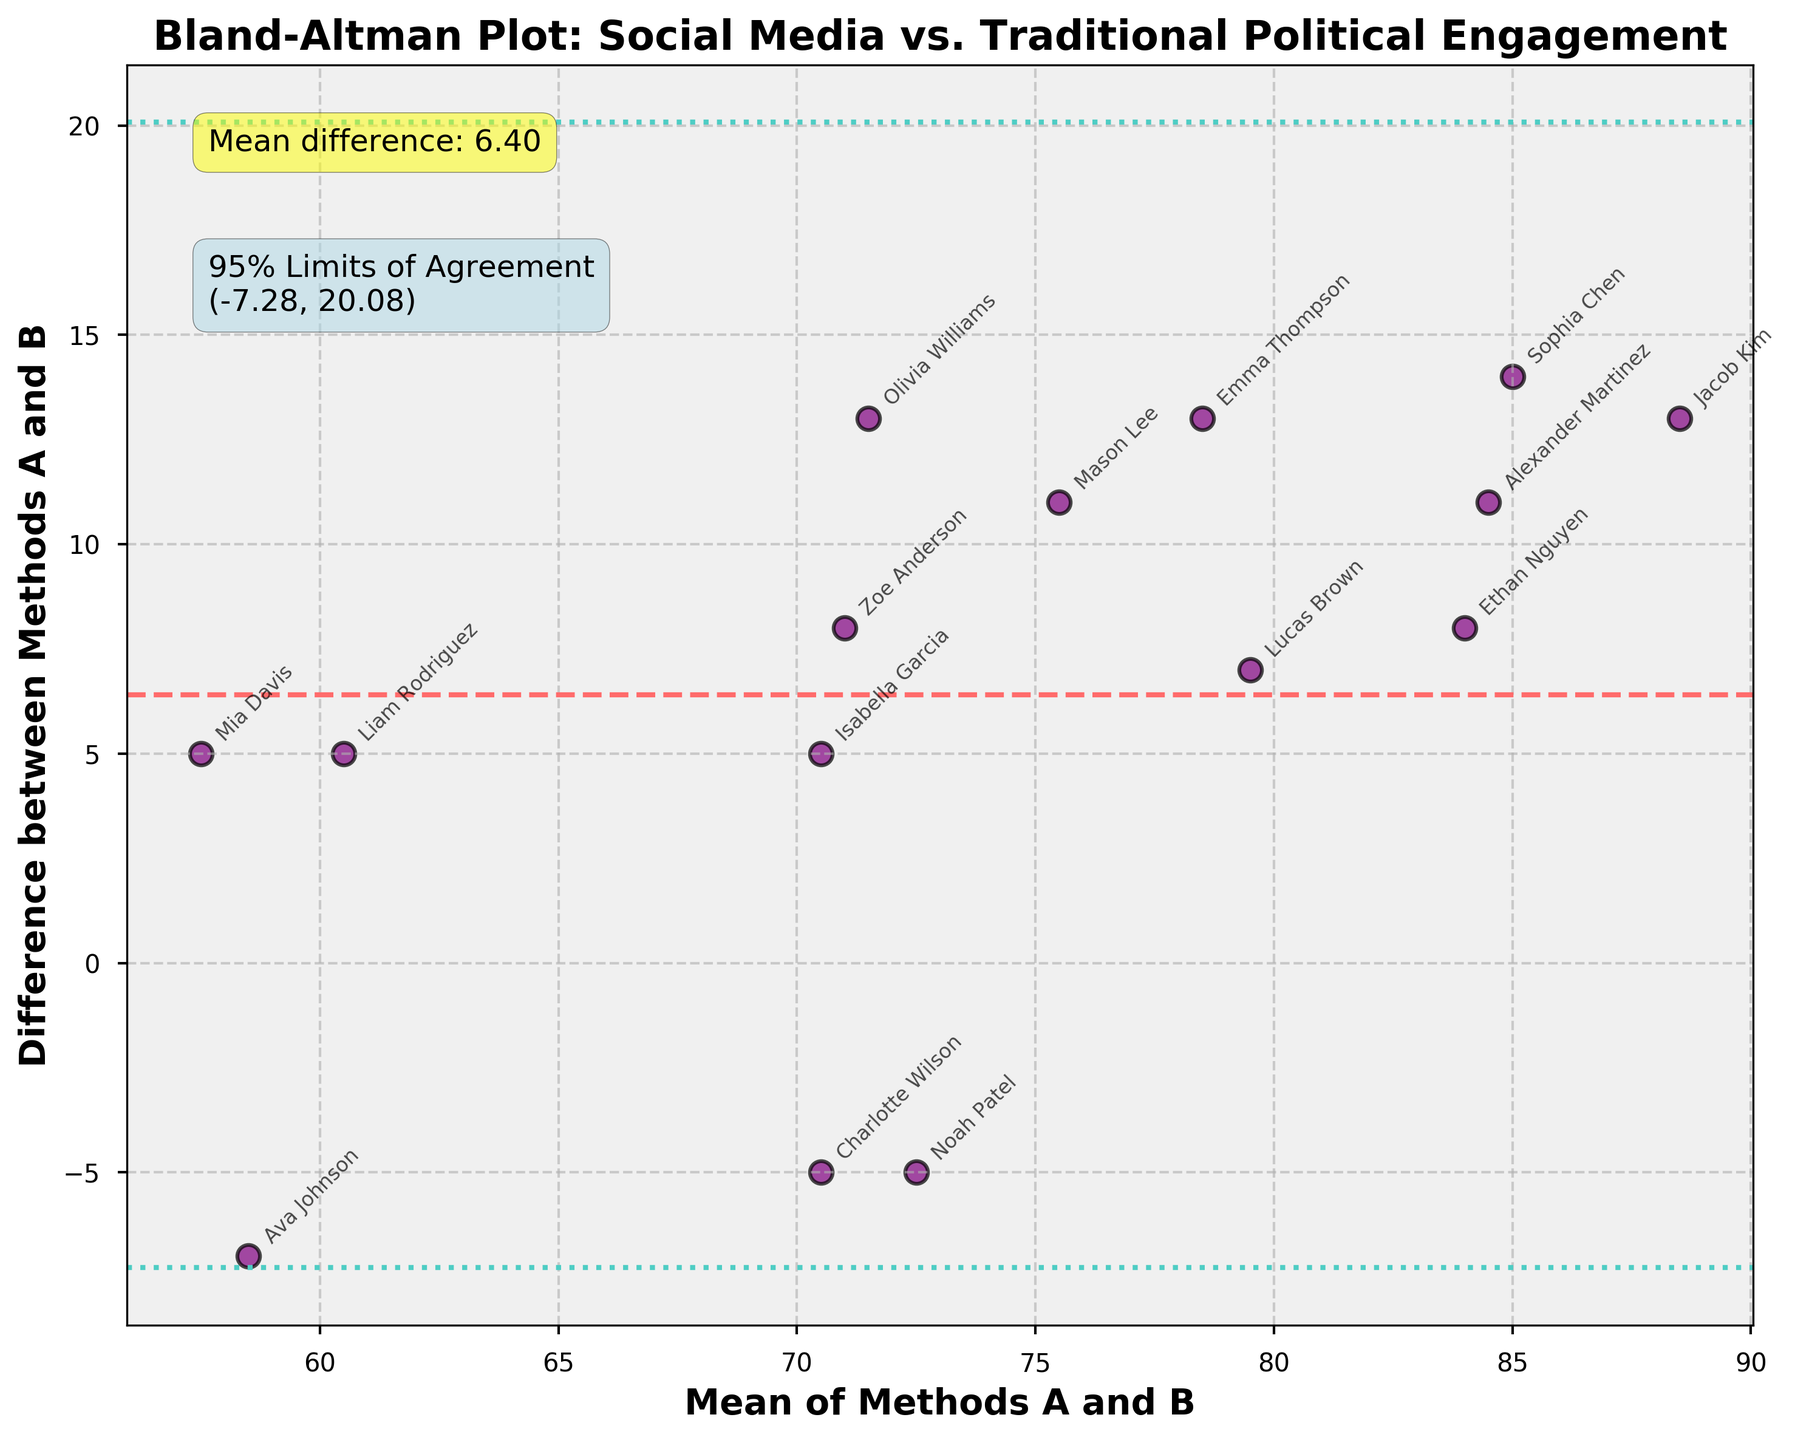What is the title of the plot? The title of the plot is written at the top and reads "Bland-Altman Plot: Social Media vs. Traditional Political Engagement".
Answer: Bland-Altman Plot: Social Media vs. Traditional Political Engagement How many data points are plotted in the figure? There is one data point for each student listed in the data table. The plot includes labels for each student, and there are 15 names annotated on the plot, indicating 15 data points.
Answer: 15 What color are the data points? The data points are shown as purple circles with black edges. This can be observed by looking at the scatter points on the plot.
Answer: Purple with black edges What is the mean difference between the scores of the two methods? The mean difference is annotated on the plot in a yellow box and is explicitly labeled as "Mean difference: 7.40".
Answer: 7.40 What are the values of the 95% limits of agreement? The 95% limits of agreement are annotated in a light blue box on the plot and are labeled as "95% Limits of Agreement (-4.70, 19.50)".
Answer: (-4.70, 19.50) Which student has the largest positive difference between the two methods? By observing the scatter points and their annotations, Jacob Kim has the largest positive difference, as his data point is the highest above the mean difference line.
Answer: Jacob Kim What is the average of the methods for Lucas Brown, and what is the corresponding difference? Find the mean of the Methods A and B scores for Lucas Brown, which are 83 and 76. The average (mean) is (83 + 76) / 2 = 79.5, and the difference is 83 - 76 = 7.
Answer: Mean: 79.5, Difference: 7 Are there any data points below the lower limit of agreement? The lower limit of agreement is -4.70. Scanning the plot, no data points are below the horizontal dashed line at -4.70.
Answer: No Which student has the smallest mean of methods, and what is their difference? By examining the 'Mean of Methods A and B' values, Ava Johnson has the smallest mean value. Her scores are 55 and 62, giving a mean of (55 + 62) / 2 = 58.5. The difference is 55 - 62 = -7.
Answer: Ava Johnson, Mean: 58.5, Difference: -7 